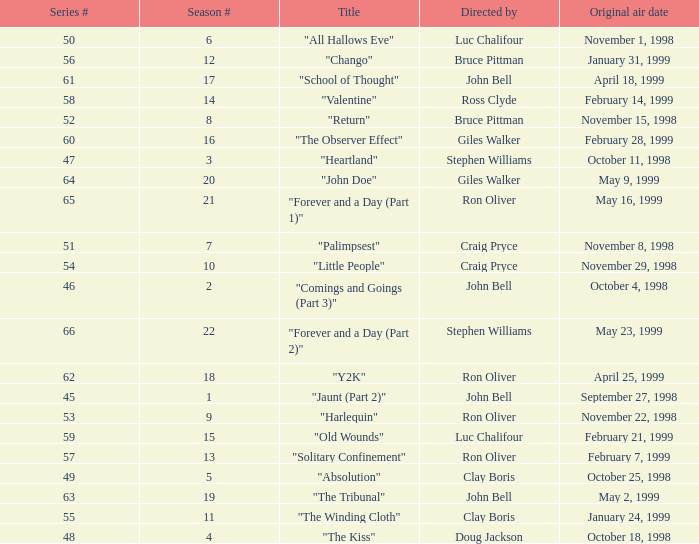Which Original air date has a Season # smaller than 21, and a Title of "palimpsest"? November 8, 1998. 